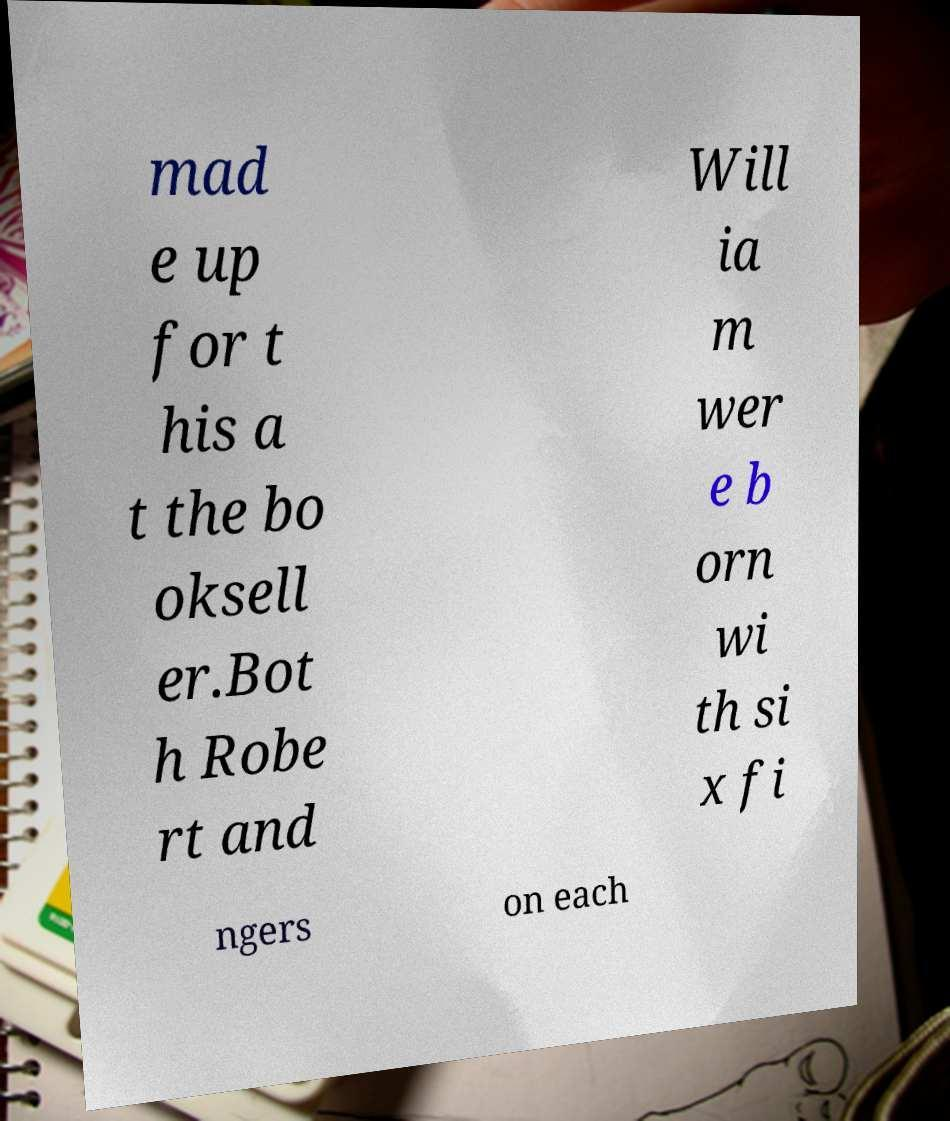There's text embedded in this image that I need extracted. Can you transcribe it verbatim? mad e up for t his a t the bo oksell er.Bot h Robe rt and Will ia m wer e b orn wi th si x fi ngers on each 